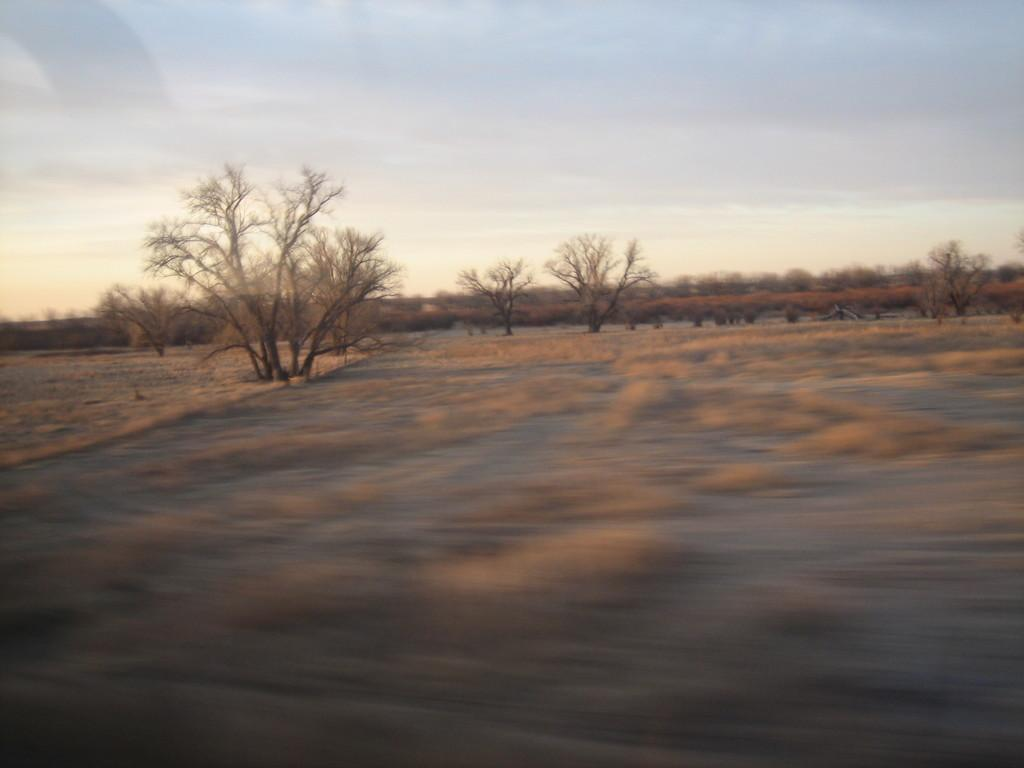What type of vegetation can be seen in the image? There are trees and plants in the image. What part of the natural environment is visible in the image? The sky is visible in the image. Can you describe the vegetation in more detail? The trees and plants in the image are not specified, but they are present. What type of berry can be seen growing on the trees in the image? There is no berry present in the image; only trees and plants are visible. Can you tell me how many jars are on the ground in the image? There is no jar present in the image; only trees, plants, and the sky are visible. 